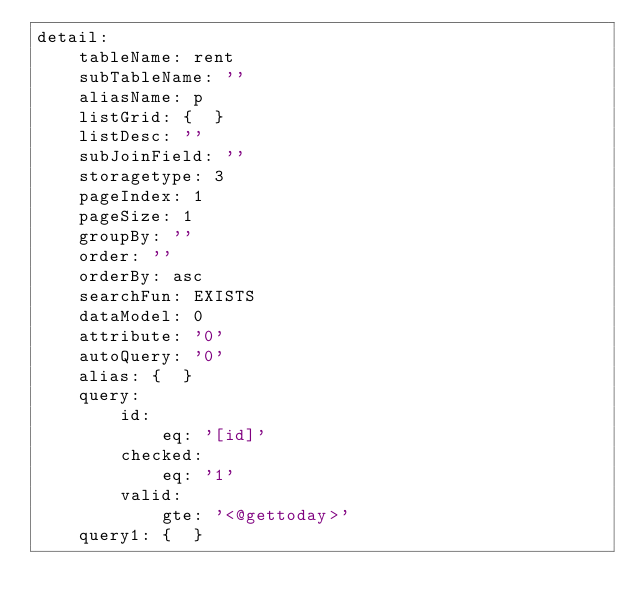Convert code to text. <code><loc_0><loc_0><loc_500><loc_500><_YAML_>detail:
    tableName: rent
    subTableName: ''
    aliasName: p
    listGrid: {  }
    listDesc: ''
    subJoinField: ''
    storagetype: 3
    pageIndex: 1
    pageSize: 1
    groupBy: ''
    order: ''
    orderBy: asc
    searchFun: EXISTS
    dataModel: 0
    attribute: '0'
    autoQuery: '0'
    alias: {  }
    query:
        id:
            eq: '[id]'
        checked:
            eq: '1'
        valid:
            gte: '<@gettoday>'
    query1: {  }</code> 